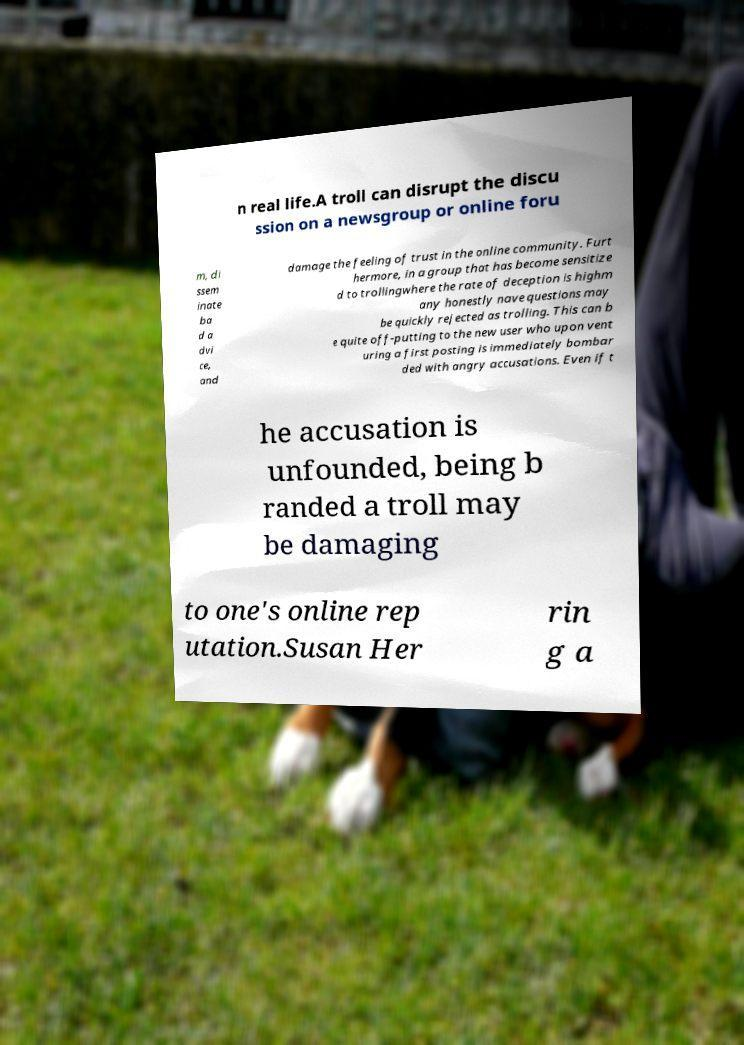Please identify and transcribe the text found in this image. n real life.A troll can disrupt the discu ssion on a newsgroup or online foru m, di ssem inate ba d a dvi ce, and damage the feeling of trust in the online community. Furt hermore, in a group that has become sensitize d to trollingwhere the rate of deception is highm any honestly nave questions may be quickly rejected as trolling. This can b e quite off-putting to the new user who upon vent uring a first posting is immediately bombar ded with angry accusations. Even if t he accusation is unfounded, being b randed a troll may be damaging to one's online rep utation.Susan Her rin g a 